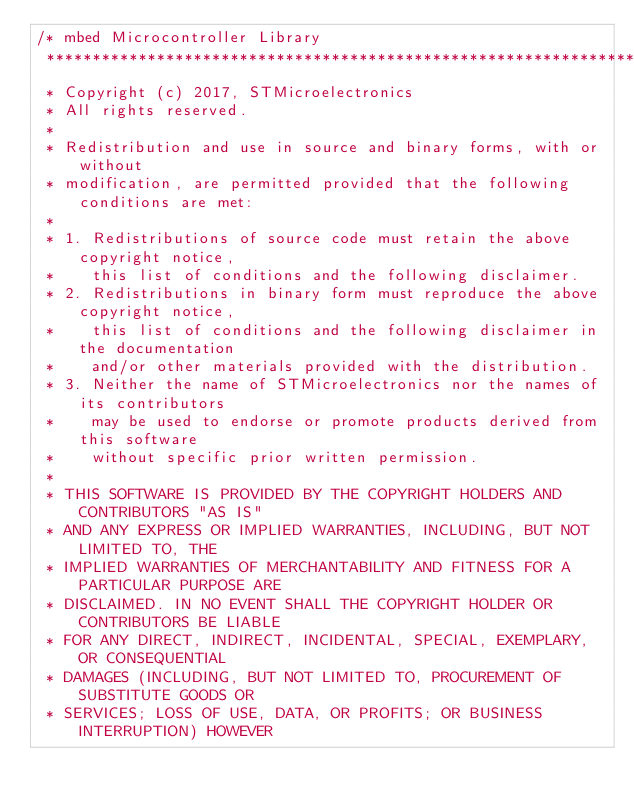<code> <loc_0><loc_0><loc_500><loc_500><_C_>/* mbed Microcontroller Library
 *******************************************************************************
 * Copyright (c) 2017, STMicroelectronics
 * All rights reserved.
 *
 * Redistribution and use in source and binary forms, with or without
 * modification, are permitted provided that the following conditions are met:
 *
 * 1. Redistributions of source code must retain the above copyright notice,
 *    this list of conditions and the following disclaimer.
 * 2. Redistributions in binary form must reproduce the above copyright notice,
 *    this list of conditions and the following disclaimer in the documentation
 *    and/or other materials provided with the distribution.
 * 3. Neither the name of STMicroelectronics nor the names of its contributors
 *    may be used to endorse or promote products derived from this software
 *    without specific prior written permission.
 *
 * THIS SOFTWARE IS PROVIDED BY THE COPYRIGHT HOLDERS AND CONTRIBUTORS "AS IS"
 * AND ANY EXPRESS OR IMPLIED WARRANTIES, INCLUDING, BUT NOT LIMITED TO, THE
 * IMPLIED WARRANTIES OF MERCHANTABILITY AND FITNESS FOR A PARTICULAR PURPOSE ARE
 * DISCLAIMED. IN NO EVENT SHALL THE COPYRIGHT HOLDER OR CONTRIBUTORS BE LIABLE
 * FOR ANY DIRECT, INDIRECT, INCIDENTAL, SPECIAL, EXEMPLARY, OR CONSEQUENTIAL
 * DAMAGES (INCLUDING, BUT NOT LIMITED TO, PROCUREMENT OF SUBSTITUTE GOODS OR
 * SERVICES; LOSS OF USE, DATA, OR PROFITS; OR BUSINESS INTERRUPTION) HOWEVER</code> 